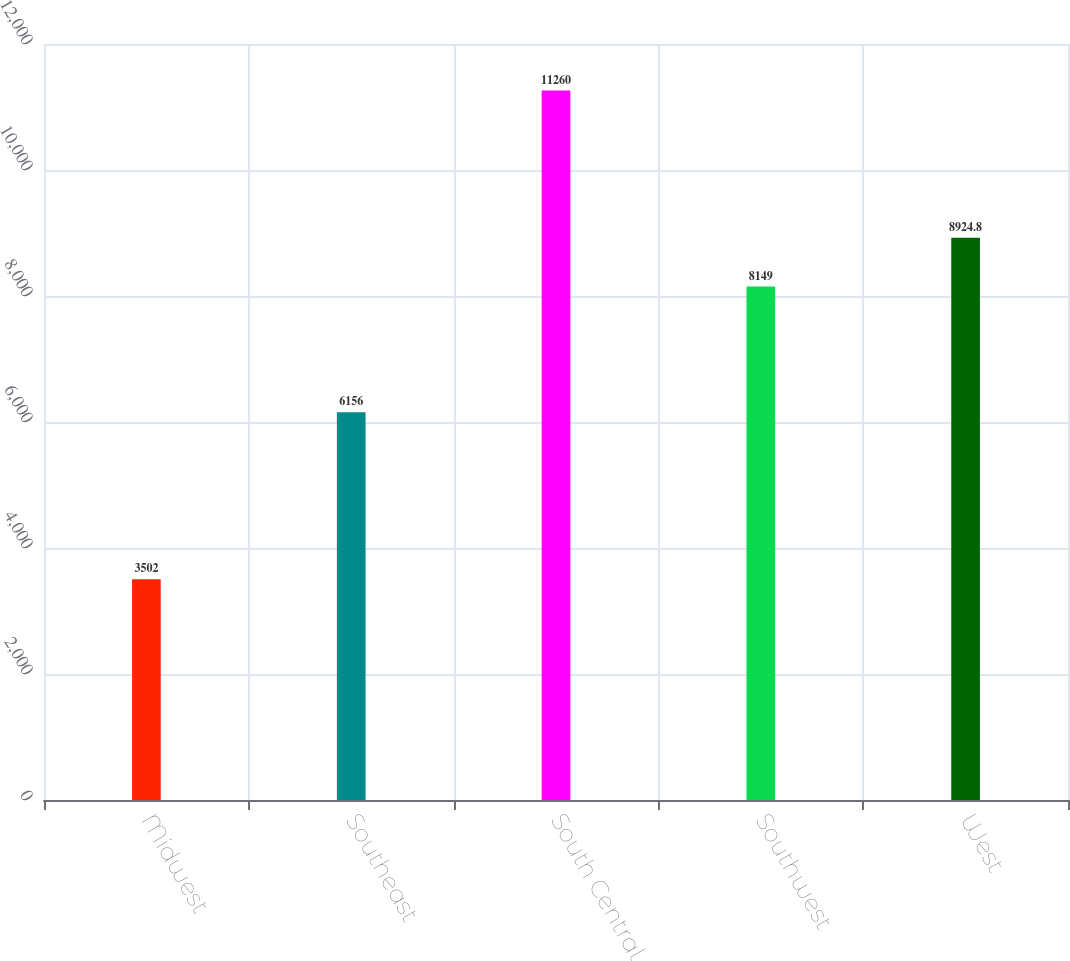<chart> <loc_0><loc_0><loc_500><loc_500><bar_chart><fcel>Midwest<fcel>Southeast<fcel>South Central<fcel>Southwest<fcel>West<nl><fcel>3502<fcel>6156<fcel>11260<fcel>8149<fcel>8924.8<nl></chart> 